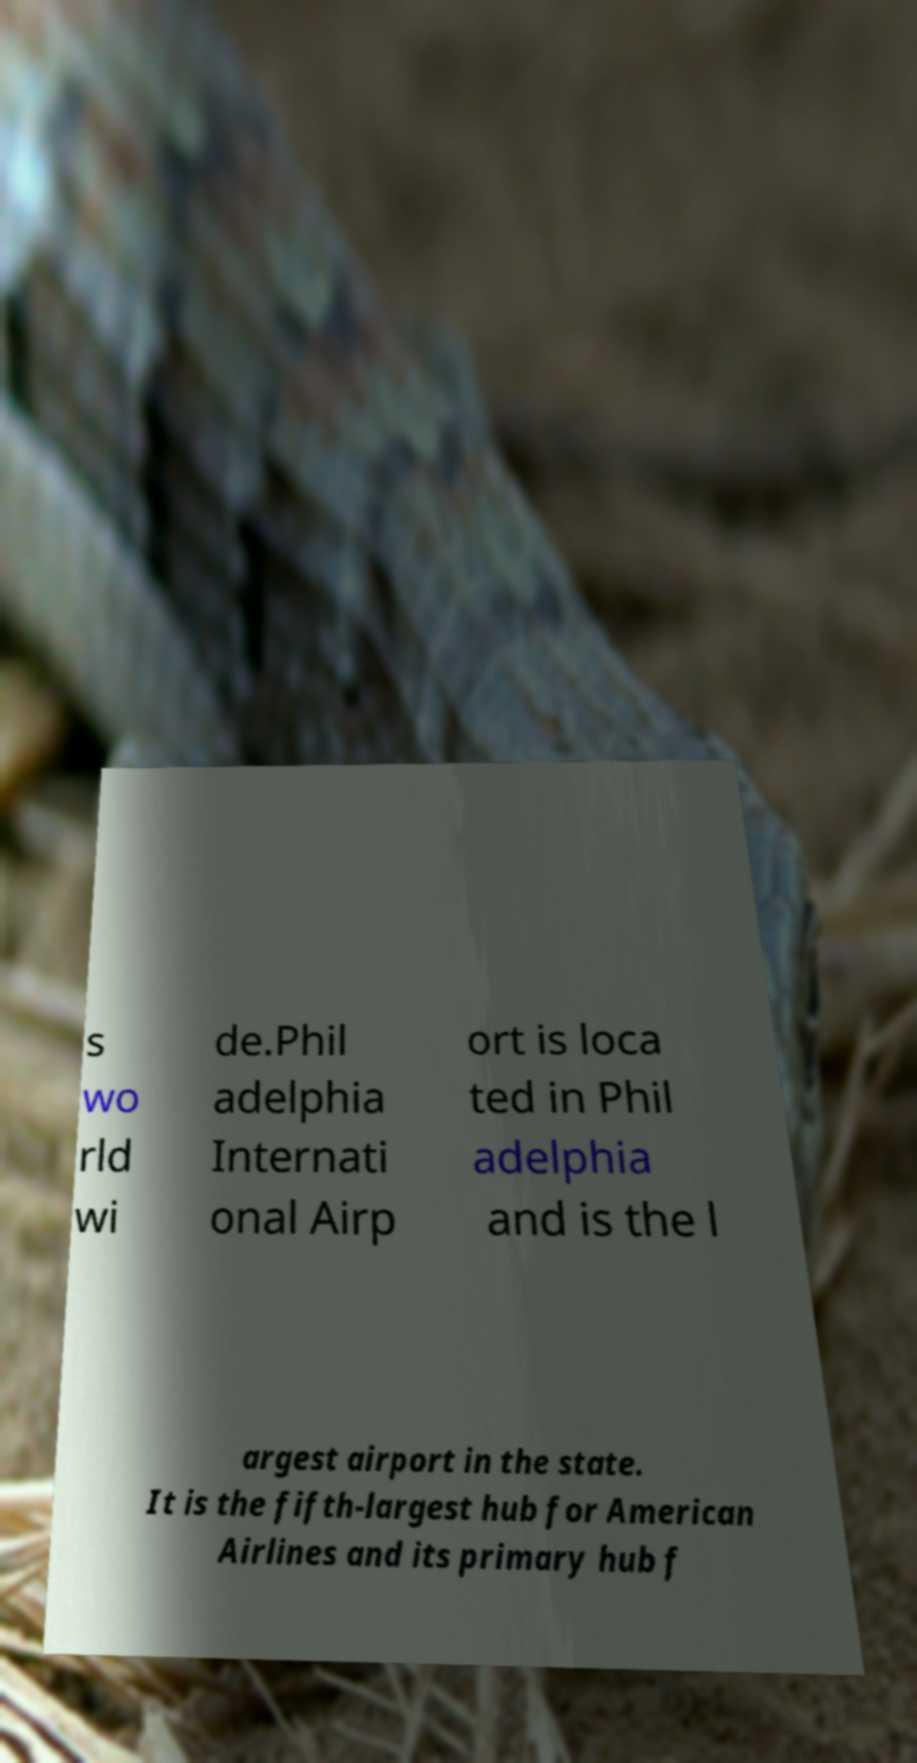Can you read and provide the text displayed in the image?This photo seems to have some interesting text. Can you extract and type it out for me? s wo rld wi de.Phil adelphia Internati onal Airp ort is loca ted in Phil adelphia and is the l argest airport in the state. It is the fifth-largest hub for American Airlines and its primary hub f 